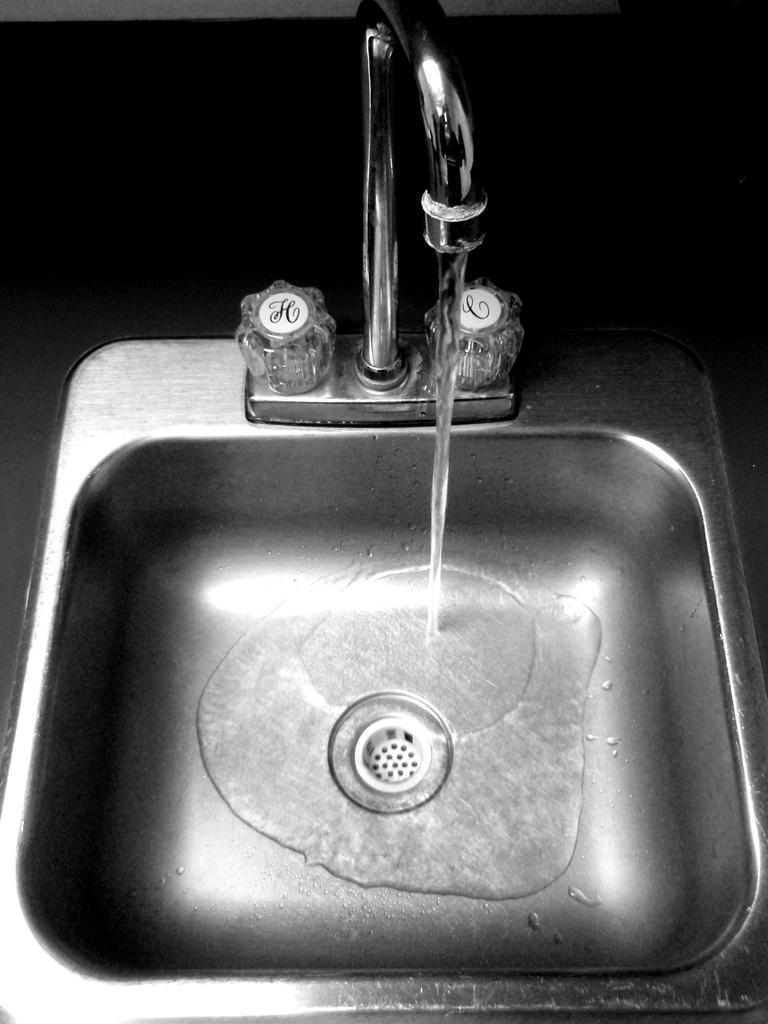What is happening with the water in the image? Water is flowing through a tap in the image. Where is the tap located? The tap is located in a sink. What type of lunch is being prepared in the image? There is no lunch preparation visible in the image; it only shows water flowing through a tap in a sink. 